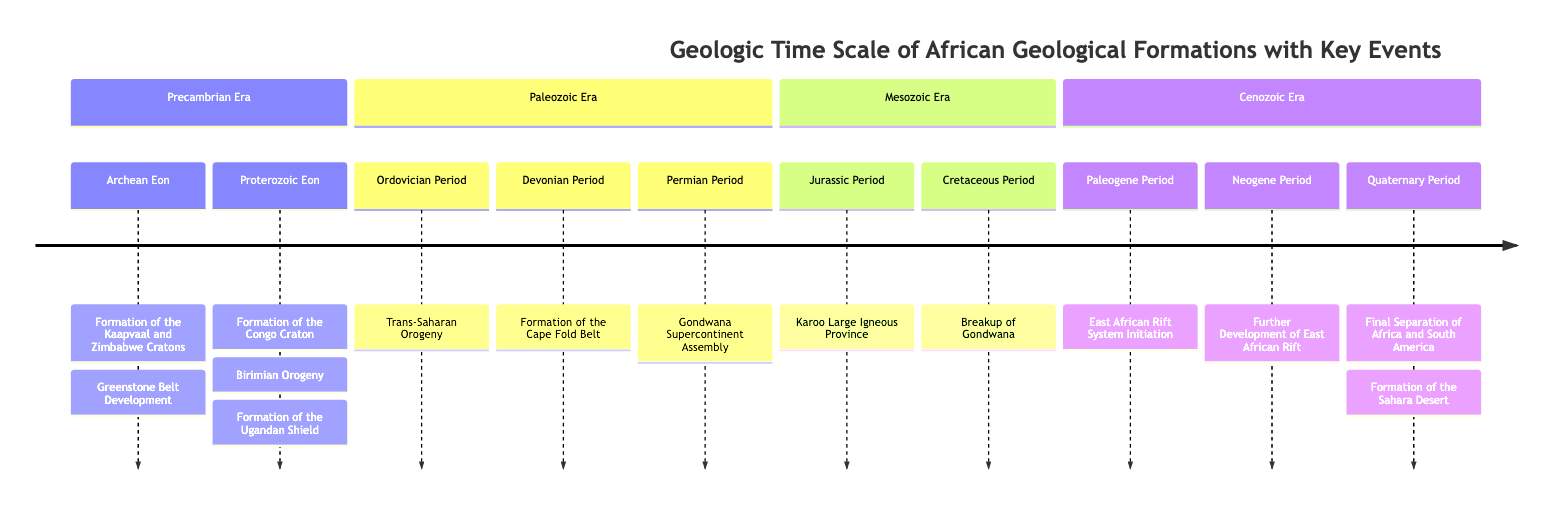What event marked the beginning of the Proterozoic Eon in Africa? The Proterozoic Eon begins with the formation of the Congo Craton, which is listed as a key event under this eon.
Answer: Formation of the Congo Craton Which geological period corresponds with the development of the Cape Fold Belt? The Cape Fold Belt formed during the Devonian Period, as indicated in the Paleozoic Era section of the diagram.
Answer: Devonian Period How many key events are associated with the Mesozoic Era? In the Mesozoic Era section, there are two key events listed: the formation of the Karoo Large Igneous Province and the breakup of Gondwana. Therefore, the count is two.
Answer: 2 Which event is associated with the Jurassic Period in the diagram? The Jurassic Period is associated with the Karoo Large Igneous Province as a key event under the Mesozoic Era section of the diagram.
Answer: Karoo Large Igneous Province What significant geological development initiated during the Paleogene Period? The East African Rift System initiation is the key event that started during the Paleogene Period, as stated in the Cenozoic Era section.
Answer: East African Rift System Initiation Which geological formation marked the final separation of Africa and South America? The final separation of Africa and South America is mentioned as a key event in the Quaternary Period of the Cenozoic Era, indicating a specific historical geological occurrence.
Answer: Final Separation of Africa and South America What distinguishes the Ordovician Period from the Devonian Period in terms of geological events? The Ordovician Period is noted for the Trans-Saharan Orogeny, while the Devonian Period is characterized by the formation of the Cape Fold Belt. This highlights the distinct geological events in both periods, showing their uniqueness in the geological timeline.
Answer: Trans-Saharan Orogeny; Formation of the Cape Fold Belt What is the last major event listed in the Cenozoic Era of the diagram? The final event listed for the Cenozoic Era is the formation of the Sahara Desert, which is indicated as a significant occurrence in the Quaternary Period.
Answer: Formation of the Sahara Desert 